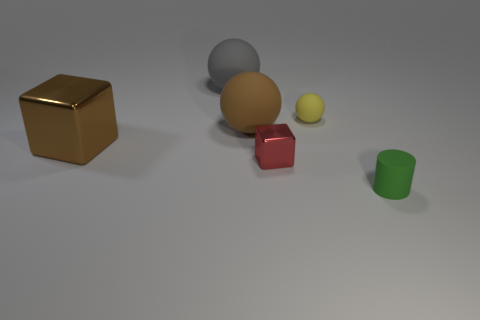How does the overall composition of the objects strike you in terms of balance and color? The composition presents a harmonious balance with a centrally placed large gray sphere flanked by an array of smaller, colorful objects on either side, creating a visually pleasing asymmetry. The colors range from muted to vivid, invoking a sense of contrast and diversity. 